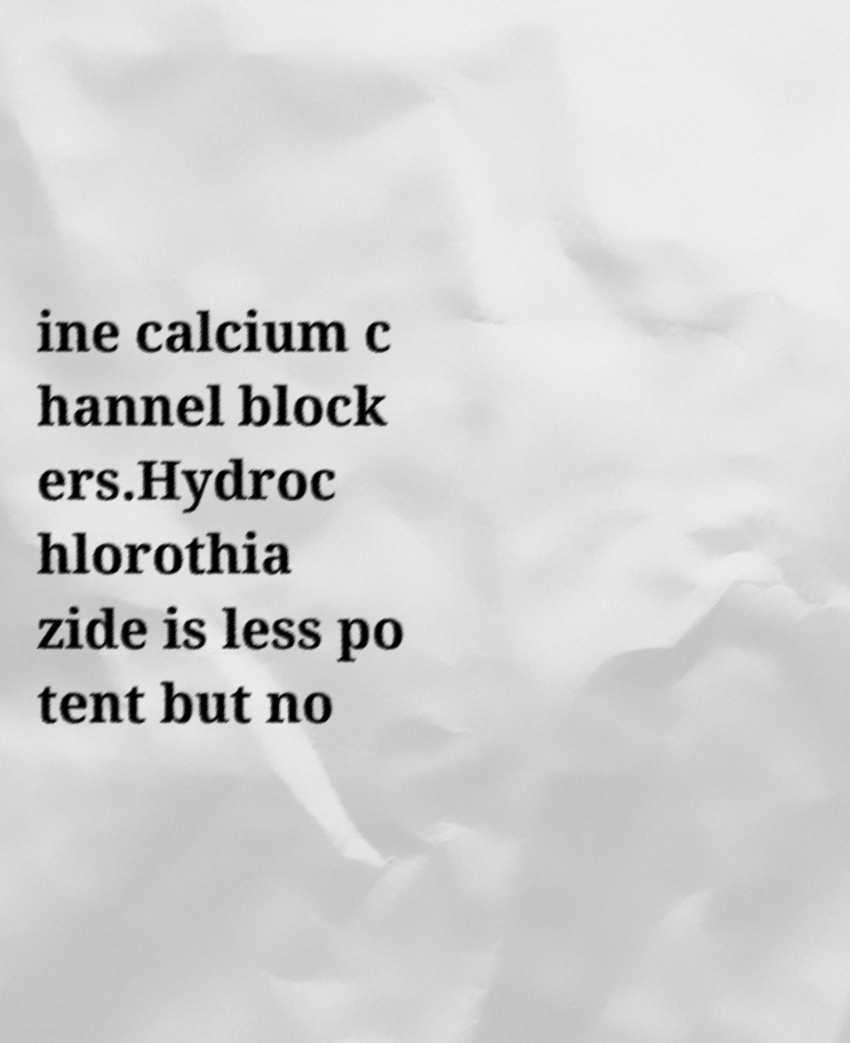For documentation purposes, I need the text within this image transcribed. Could you provide that? ine calcium c hannel block ers.Hydroc hlorothia zide is less po tent but no 